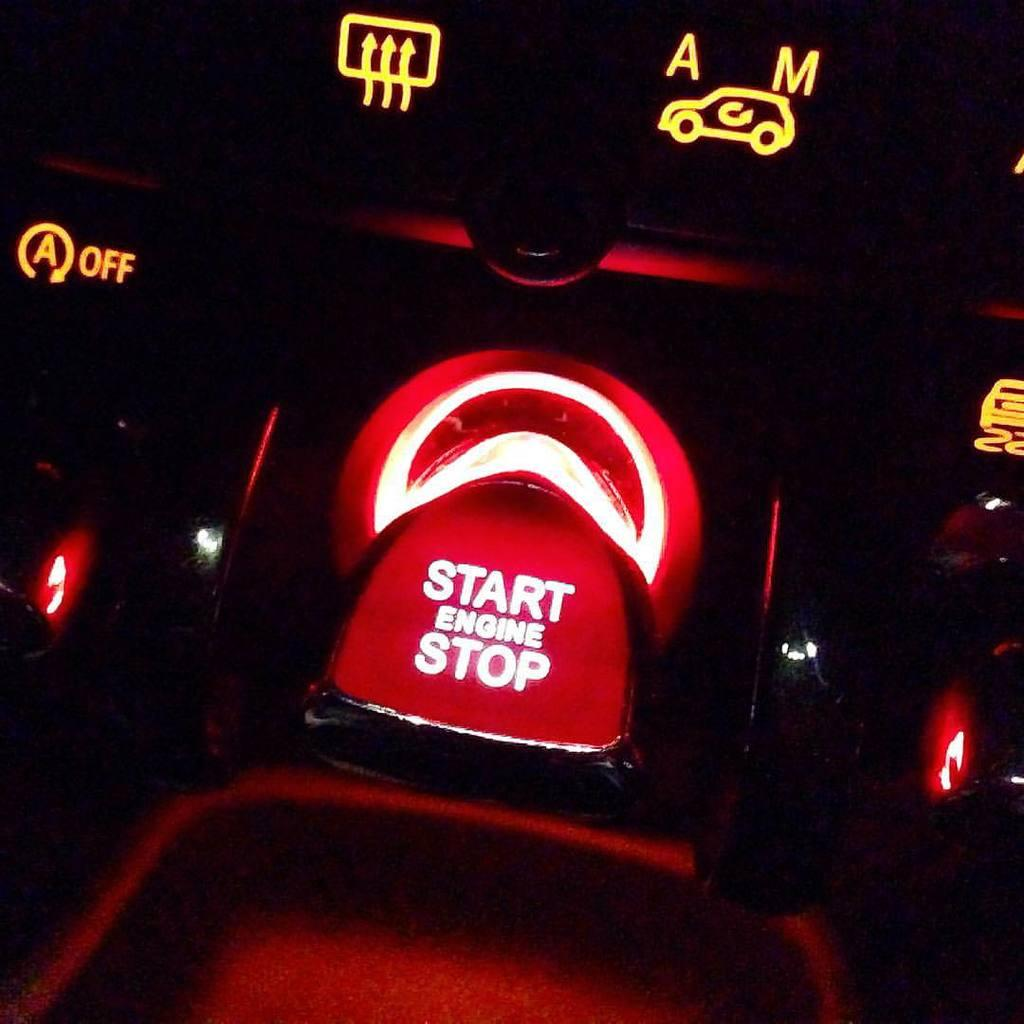What color is the prominent object in the image? The prominent object in the image is red. What text is written on the red object? The words "start engine stop" are written on the red object. What color is the background of the image? The background of the image is black. Who is the owner of the plane in the image? There is no plane present in the image, so it is not possible to determine the owner. 